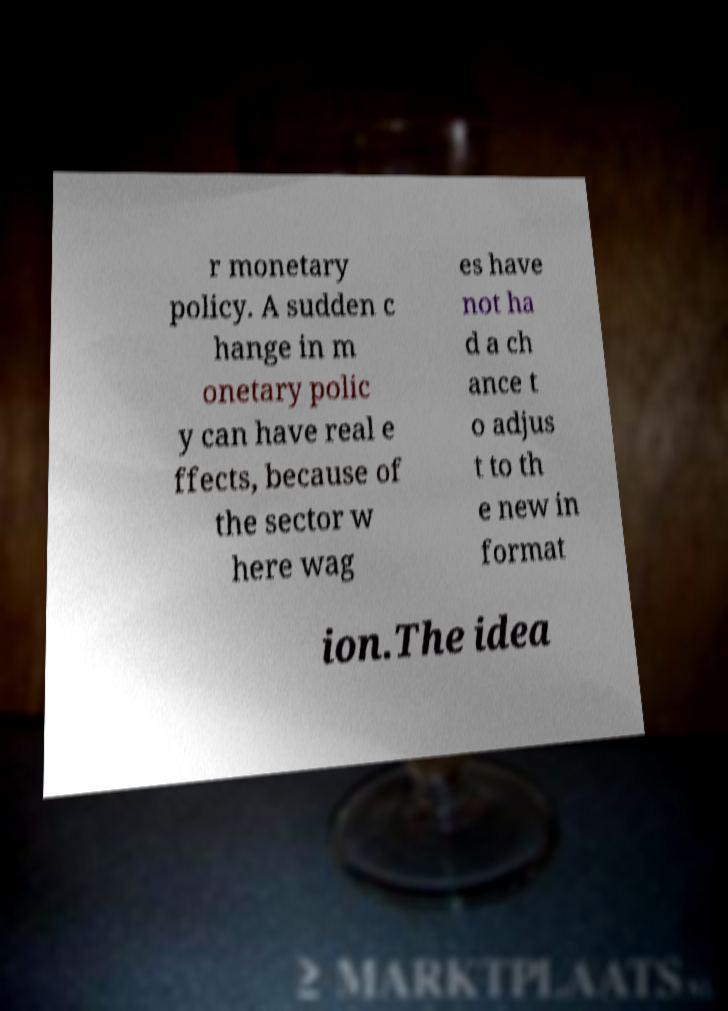There's text embedded in this image that I need extracted. Can you transcribe it verbatim? r monetary policy. A sudden c hange in m onetary polic y can have real e ffects, because of the sector w here wag es have not ha d a ch ance t o adjus t to th e new in format ion.The idea 